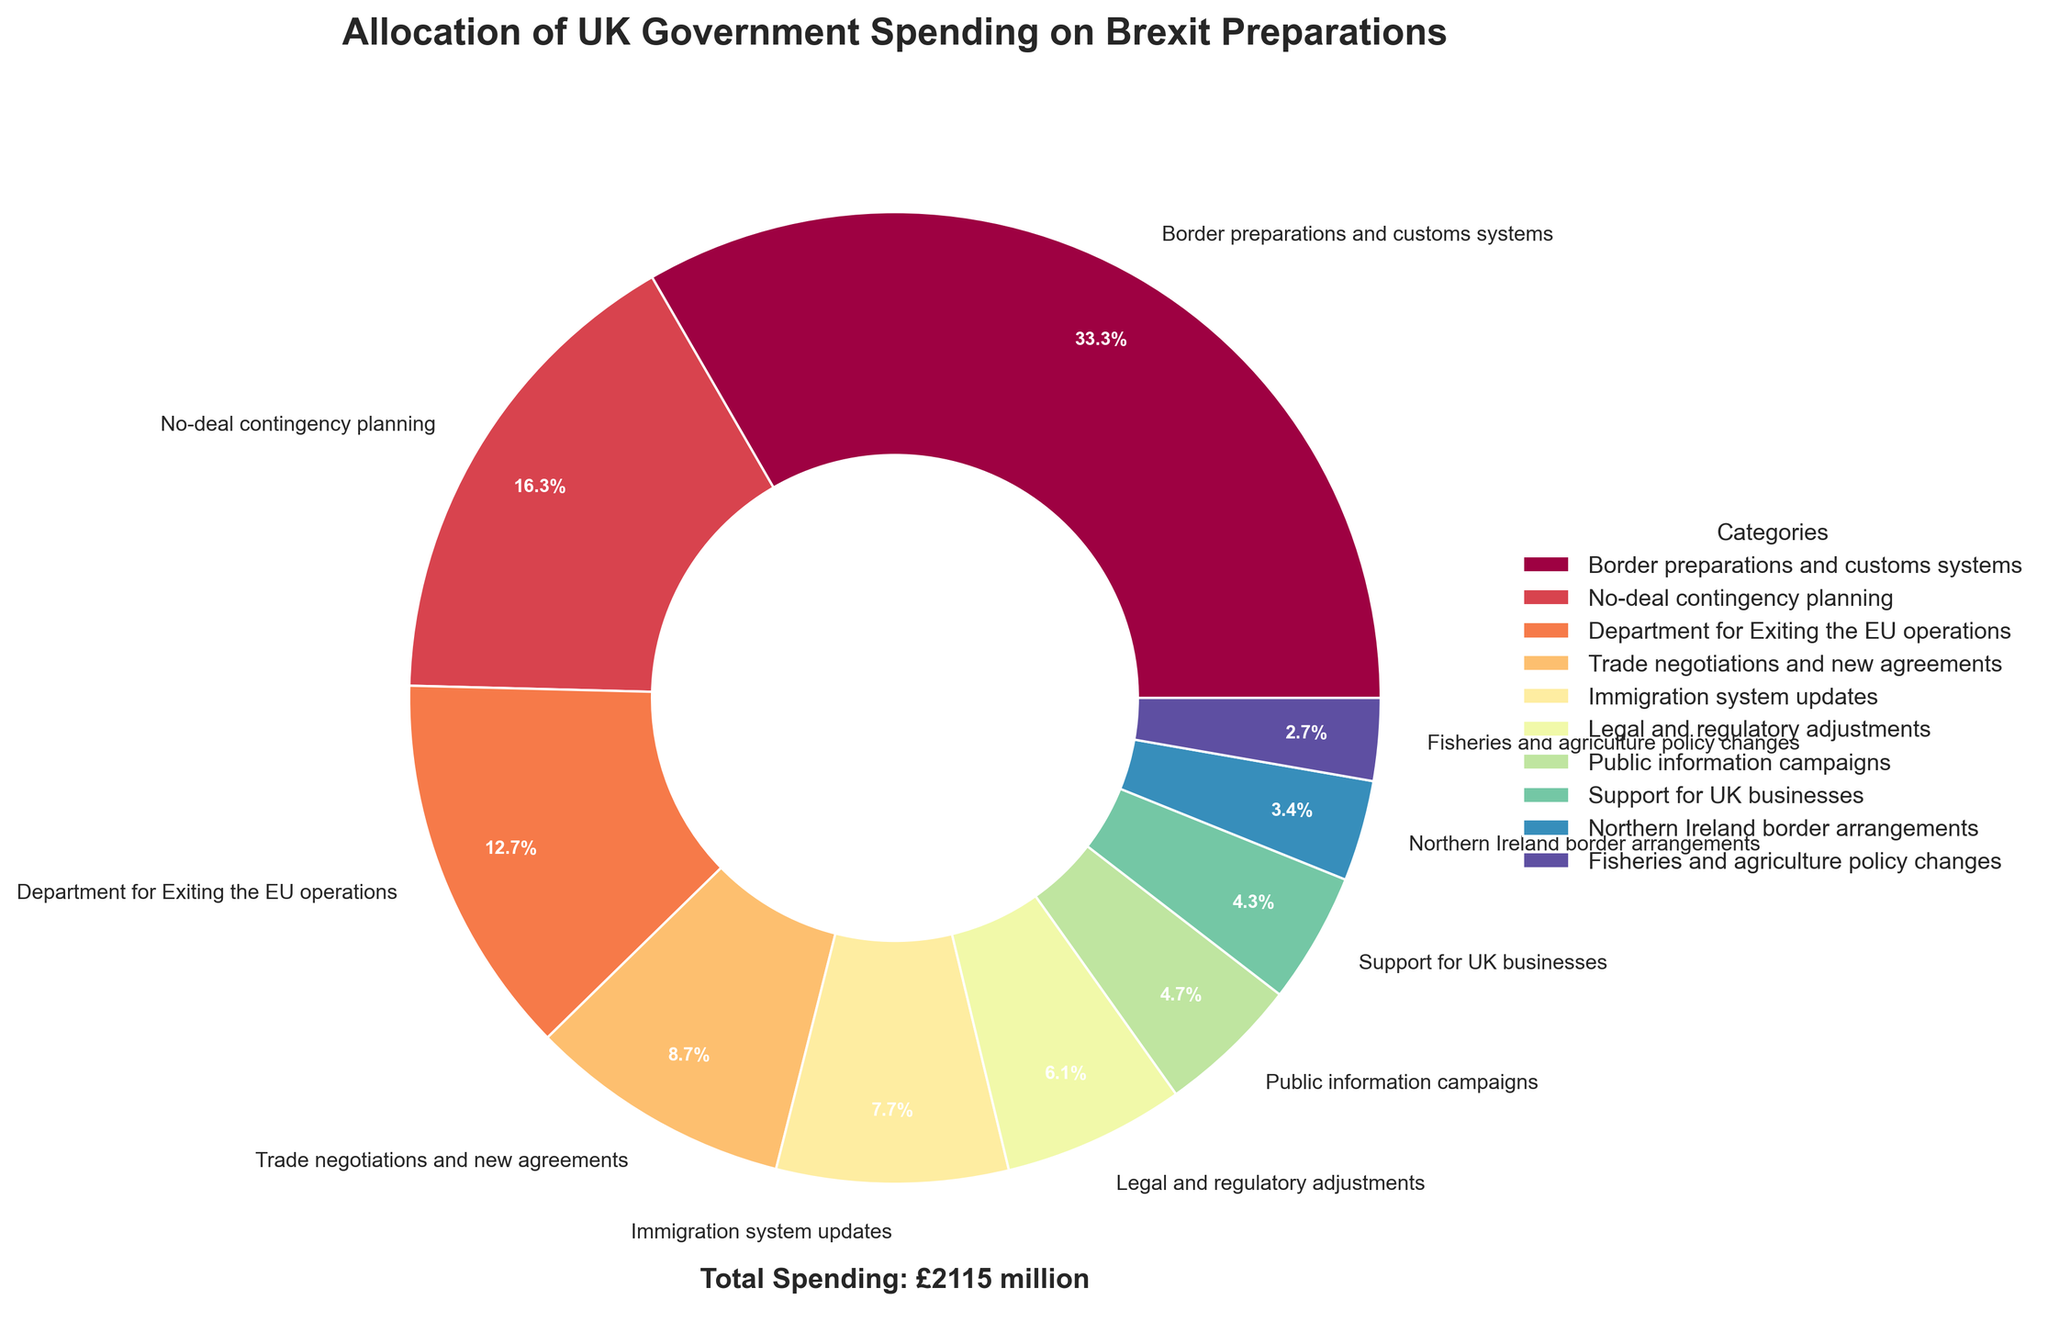What is the largest category of spending for Brexit preparations? The figure clearly shows that the largest segment in the pie chart corresponds to "Border preparations and customs systems." This segment not only takes up the largest portion visually but also has the highest value of £705 million.
Answer: Border preparations and customs systems Which category has the least amount of spending? By examining the smallest wedge in the pie chart, it's clear that the "Fisheries and agriculture policy changes" category has the least amount of spending, totaling £58 million.
Answer: Fisheries and agriculture policy changes How much more has been spent on border preparations and customs systems compared to Northern Ireland border arrangements? First, identify the spending for both categories from the figure: "Border preparations and customs systems" has £705 million, and "Northern Ireland border arrangements" has £71 million. The difference is calculated as £705 - £71, which equals £634 million.
Answer: £634 million Which areas have spending between £100 million and £200 million? In the pie chart, the categories that fall within this spending range are "Trade negotiations and new agreements" at £185 million, and "Immigration system updates" at £163 million.
Answer: Trade negotiations and new agreements, Immigration system updates What percentage of the total budget is allocated to no-deal contingency planning? The pie chart indicates that the "No-deal contingency planning" segment accounts for 344 out of the total spending figure of 2115 (sum of all the segments). The percentage is calculated as (344 / 2115) * 100. This equals approximately 16.3%.
Answer: 16.3% Compare the spending for public information campaigns and support for UK businesses. Which one is higher, and by how much? From the figure, "Public information campaigns" has £100 million allocated, while "Support for UK businesses" has £92 million. The difference is calculated as £100 - £92, which equals £8 million. Therefore, public information campaigns have a higher spending by £8 million.
Answer: Public information campaigns by £8 million What is the sum of spending on Department for Exiting the EU operations and legal and regulatory adjustments? The figure shows £269 million for "Department for Exiting the EU operations" and £128 million for "Legal and regulatory adjustments." The sum is calculated as £269 + £128, which equals £397 million.
Answer: £397 million What is the average spending across all categories? First, sum up the total spending which is £705 + £344 + £269 + £185 + £163 + £128 + £100 + £92 + £71 + £58 = £2115 million. Then, divide this total by the number of categories, which is 10. The average spending is calculated as £2115 / 10, which equals £211.5 million.
Answer: £211.5 million 